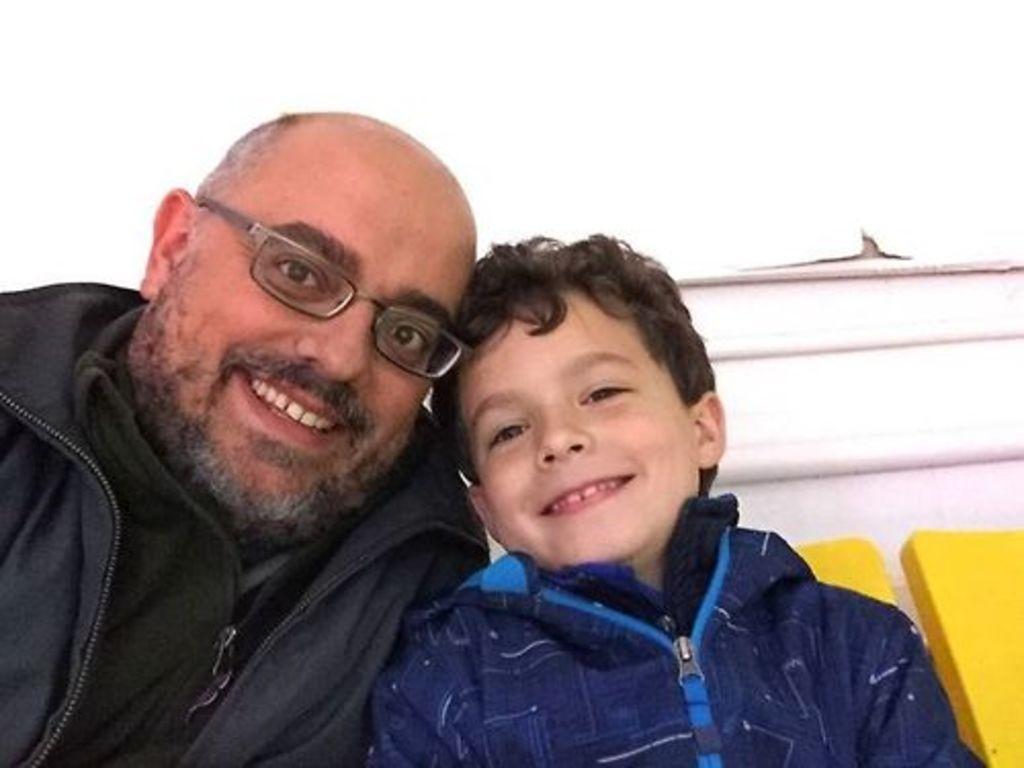How would you summarize this image in a sentence or two? In this picture I can see a man and a boy seated and I can see smile on their faces and men wore spectacles and I can see white color background. 